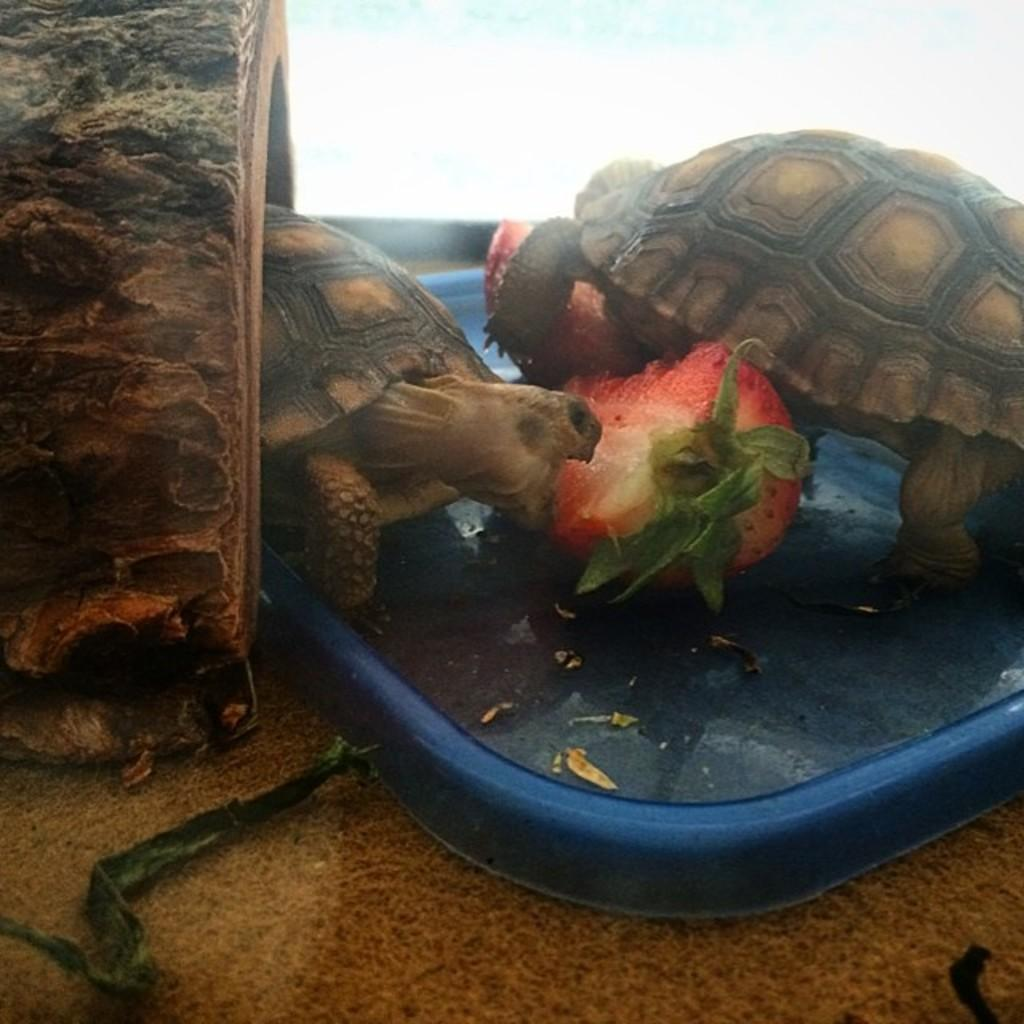How many tortoises are in the image? There are two tortoises in the image. What are the tortoises resting on? The tortoises are on a blue object. What is located between the tortoises? There is a fruit between the tortoises. What can be seen on the left side of the tortoises? There is a wooden item on the left side of the tortoises. What type of pipe is the tortoise smoking in the image? There is no pipe present in the image, and tortoises do not smoke. 